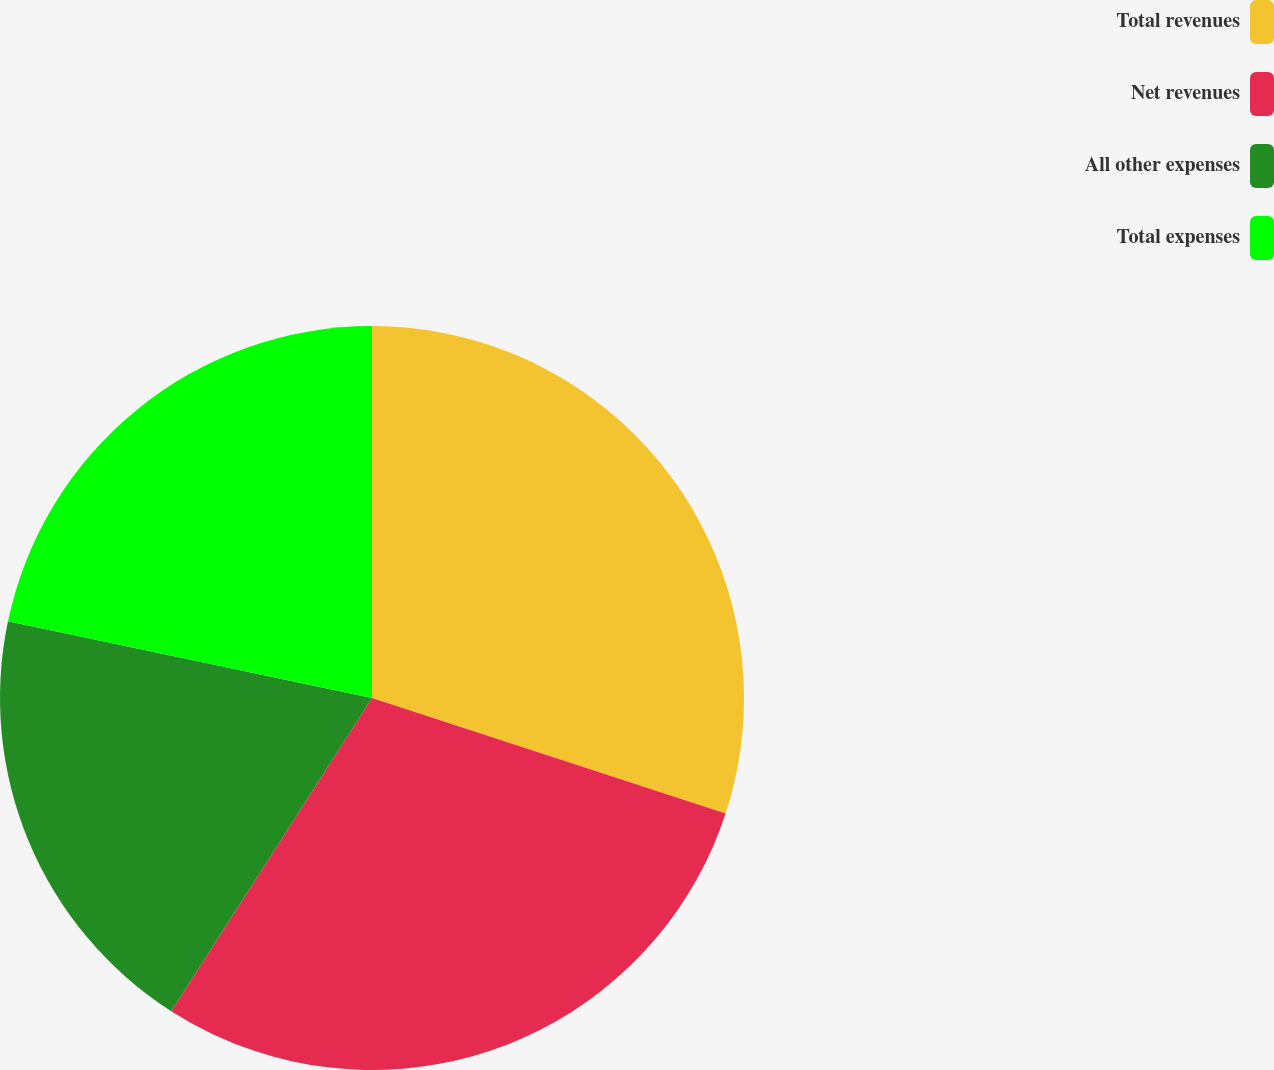Convert chart. <chart><loc_0><loc_0><loc_500><loc_500><pie_chart><fcel>Total revenues<fcel>Net revenues<fcel>All other expenses<fcel>Total expenses<nl><fcel>30.03%<fcel>29.05%<fcel>19.23%<fcel>21.7%<nl></chart> 